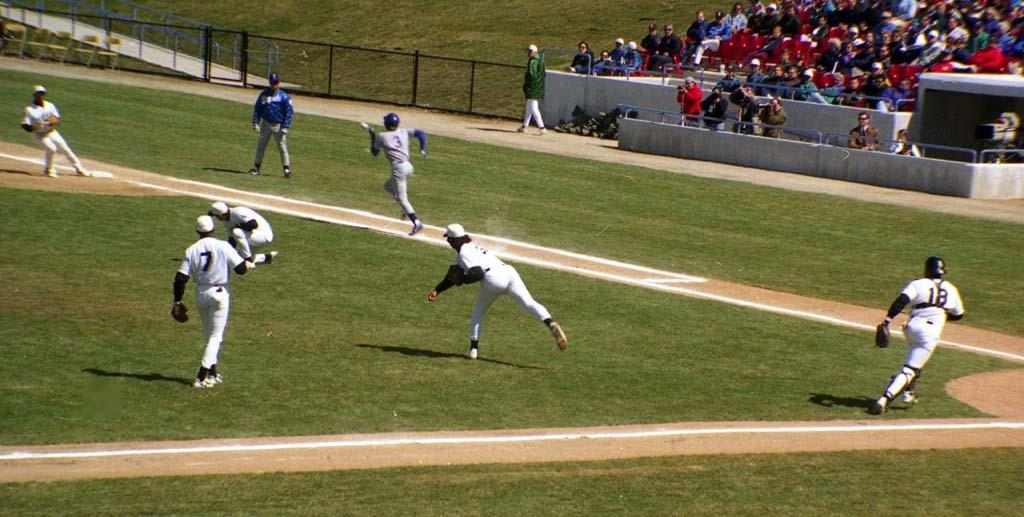What are the sports persons doing in the image? The sports persons are on the ground, which suggests they are engaged in some form of sports activity. What can be seen in the background of the image? There is a fence, railings, some objects, and a crowd visible in the background. Can you describe the fence in the background? The fact only mentions that there is a fence in the background, but it does not provide any details about its appearance or construction. What rate is the sports person teaching the crowd in the image? There is no indication in the image that the sports person is teaching the crowd, nor is there any mention of a rate. 